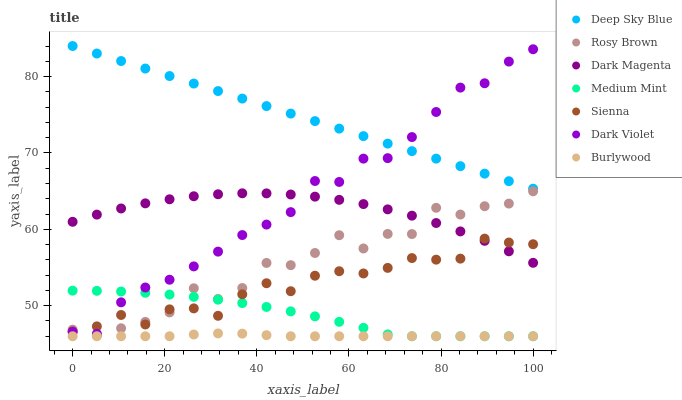Does Burlywood have the minimum area under the curve?
Answer yes or no. Yes. Does Deep Sky Blue have the maximum area under the curve?
Answer yes or no. Yes. Does Dark Magenta have the minimum area under the curve?
Answer yes or no. No. Does Dark Magenta have the maximum area under the curve?
Answer yes or no. No. Is Deep Sky Blue the smoothest?
Answer yes or no. Yes. Is Rosy Brown the roughest?
Answer yes or no. Yes. Is Dark Magenta the smoothest?
Answer yes or no. No. Is Dark Magenta the roughest?
Answer yes or no. No. Does Medium Mint have the lowest value?
Answer yes or no. Yes. Does Dark Magenta have the lowest value?
Answer yes or no. No. Does Deep Sky Blue have the highest value?
Answer yes or no. Yes. Does Dark Magenta have the highest value?
Answer yes or no. No. Is Medium Mint less than Dark Magenta?
Answer yes or no. Yes. Is Rosy Brown greater than Burlywood?
Answer yes or no. Yes. Does Dark Violet intersect Rosy Brown?
Answer yes or no. Yes. Is Dark Violet less than Rosy Brown?
Answer yes or no. No. Is Dark Violet greater than Rosy Brown?
Answer yes or no. No. Does Medium Mint intersect Dark Magenta?
Answer yes or no. No. 